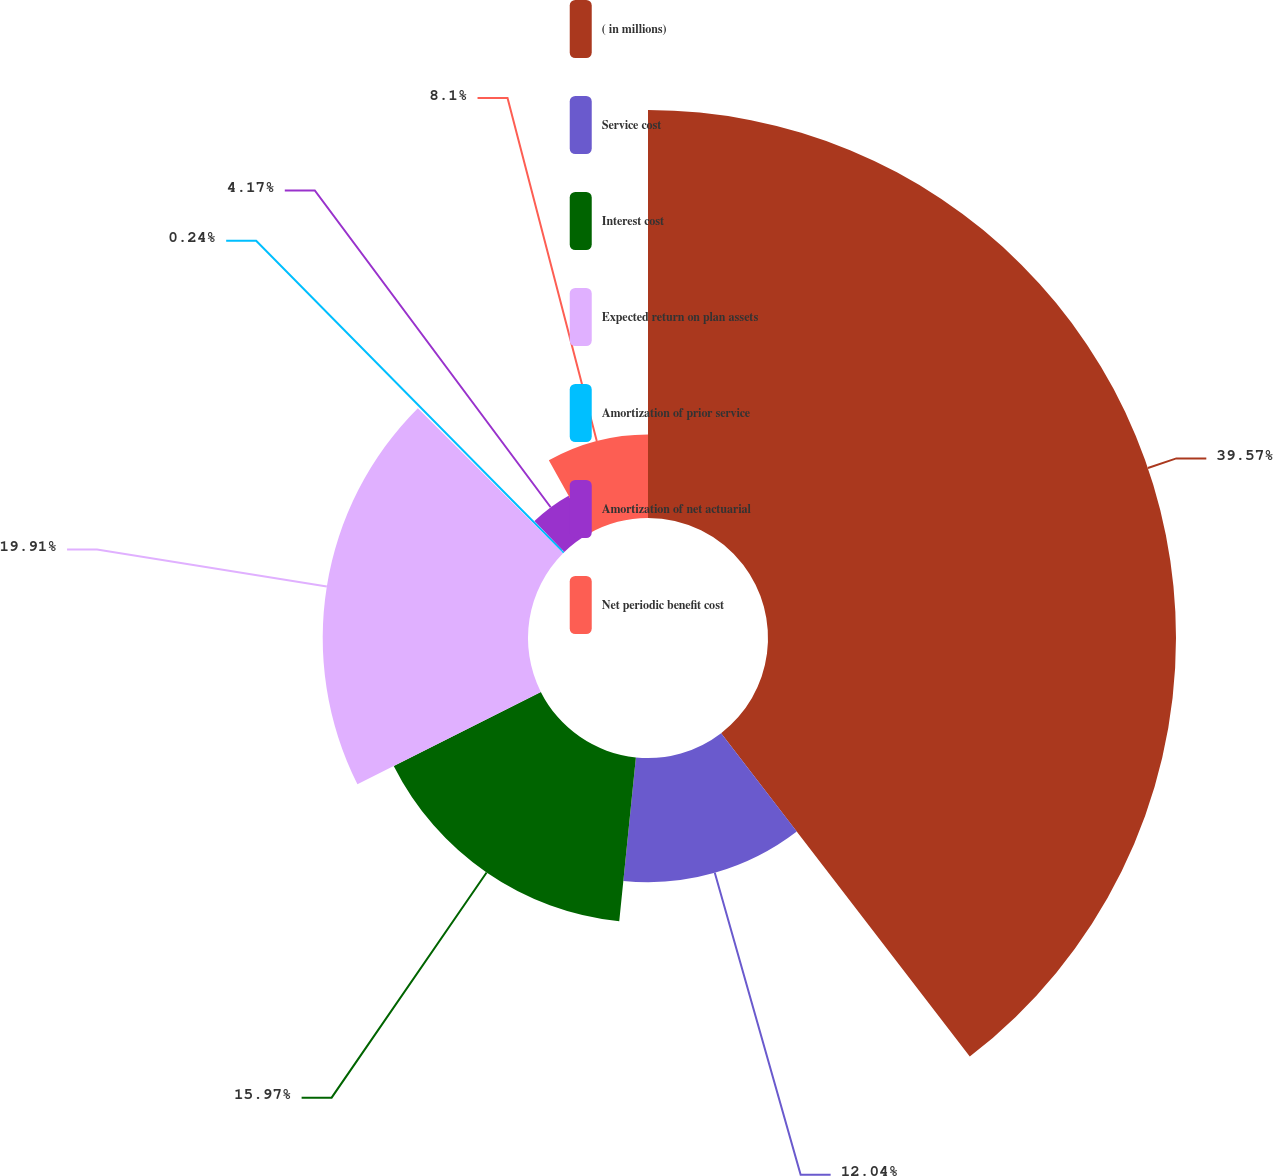Convert chart. <chart><loc_0><loc_0><loc_500><loc_500><pie_chart><fcel>( in millions)<fcel>Service cost<fcel>Interest cost<fcel>Expected return on plan assets<fcel>Amortization of prior service<fcel>Amortization of net actuarial<fcel>Net periodic benefit cost<nl><fcel>39.57%<fcel>12.04%<fcel>15.97%<fcel>19.91%<fcel>0.24%<fcel>4.17%<fcel>8.1%<nl></chart> 